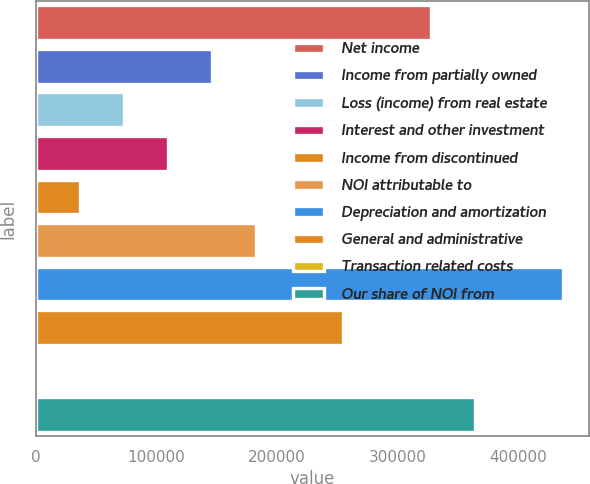Convert chart. <chart><loc_0><loc_0><loc_500><loc_500><bar_chart><fcel>Net income<fcel>Income from partially owned<fcel>Loss (income) from real estate<fcel>Interest and other investment<fcel>Income from discontinued<fcel>NOI attributable to<fcel>Depreciation and amortization<fcel>General and administrative<fcel>Transaction related costs<fcel>Our share of NOI from<nl><fcel>327542<fcel>145965<fcel>73333.8<fcel>109649<fcel>37018.4<fcel>182280<fcel>436488<fcel>254911<fcel>703<fcel>363857<nl></chart> 